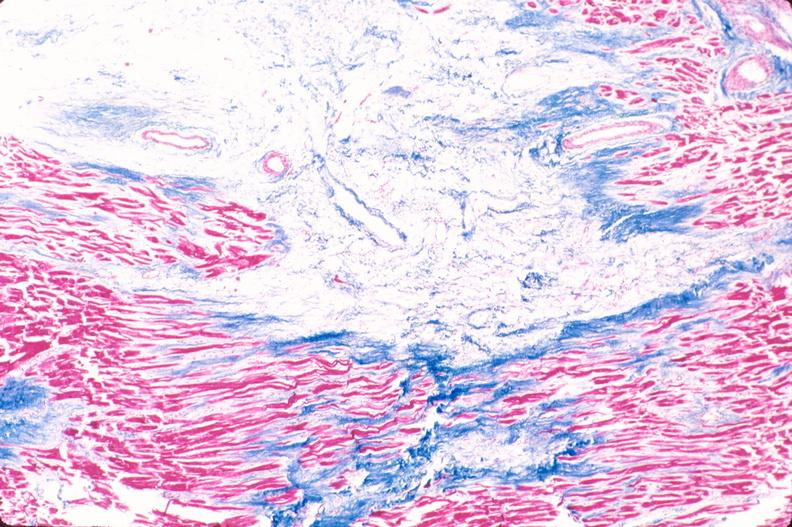does notochord show heart, old myocardial infarction with fibrosis, trichrome?
Answer the question using a single word or phrase. No 